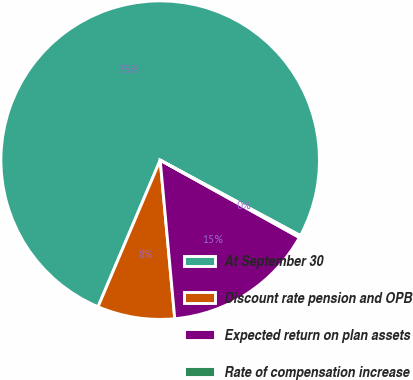Convert chart to OTSL. <chart><loc_0><loc_0><loc_500><loc_500><pie_chart><fcel>At September 30<fcel>Discount rate pension and OPB<fcel>Expected return on plan assets<fcel>Rate of compensation increase<nl><fcel>76.49%<fcel>7.84%<fcel>15.47%<fcel>0.21%<nl></chart> 